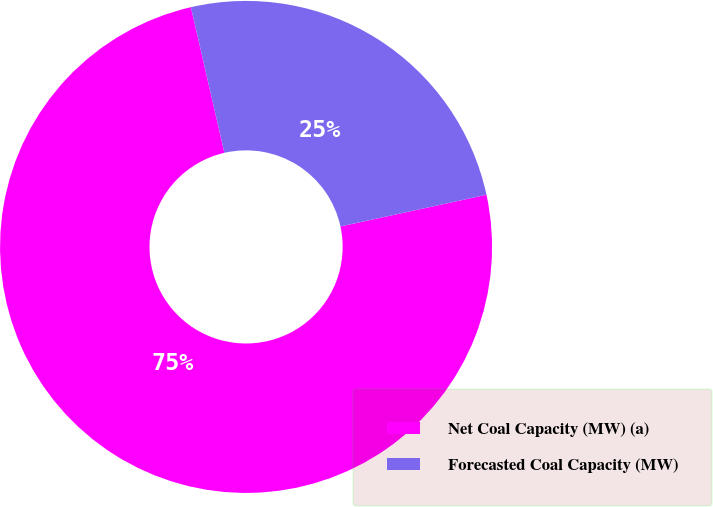Convert chart. <chart><loc_0><loc_0><loc_500><loc_500><pie_chart><fcel>Net Coal Capacity (MW) (a)<fcel>Forecasted Coal Capacity (MW)<nl><fcel>74.8%<fcel>25.2%<nl></chart> 